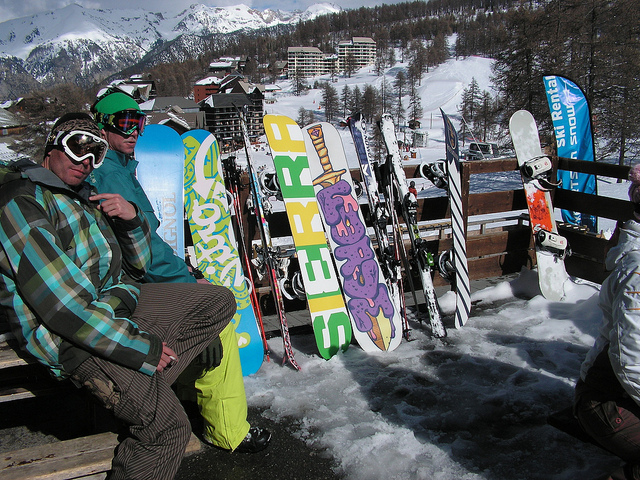Extract all visible text content from this image. SERRA Rental SKI vitro 